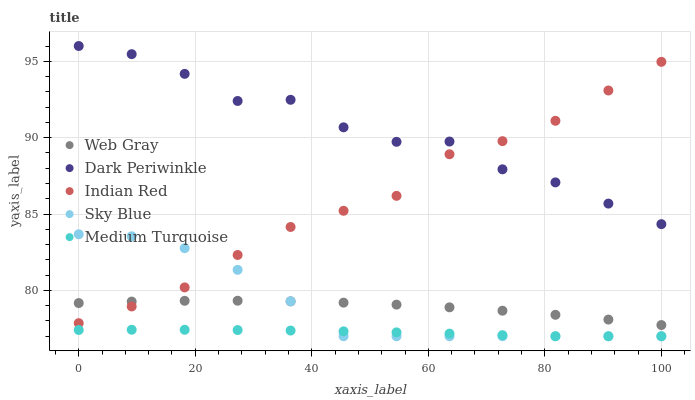Does Medium Turquoise have the minimum area under the curve?
Answer yes or no. Yes. Does Dark Periwinkle have the maximum area under the curve?
Answer yes or no. Yes. Does Web Gray have the minimum area under the curve?
Answer yes or no. No. Does Web Gray have the maximum area under the curve?
Answer yes or no. No. Is Medium Turquoise the smoothest?
Answer yes or no. Yes. Is Dark Periwinkle the roughest?
Answer yes or no. Yes. Is Web Gray the smoothest?
Answer yes or no. No. Is Web Gray the roughest?
Answer yes or no. No. Does Sky Blue have the lowest value?
Answer yes or no. Yes. Does Web Gray have the lowest value?
Answer yes or no. No. Does Dark Periwinkle have the highest value?
Answer yes or no. Yes. Does Web Gray have the highest value?
Answer yes or no. No. Is Medium Turquoise less than Web Gray?
Answer yes or no. Yes. Is Dark Periwinkle greater than Sky Blue?
Answer yes or no. Yes. Does Web Gray intersect Sky Blue?
Answer yes or no. Yes. Is Web Gray less than Sky Blue?
Answer yes or no. No. Is Web Gray greater than Sky Blue?
Answer yes or no. No. Does Medium Turquoise intersect Web Gray?
Answer yes or no. No. 